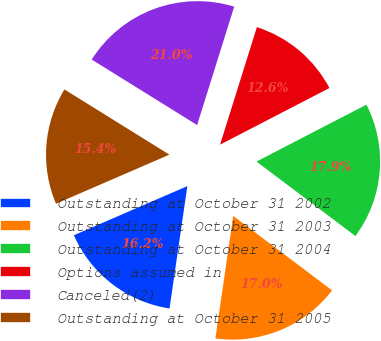Convert chart to OTSL. <chart><loc_0><loc_0><loc_500><loc_500><pie_chart><fcel>Outstanding at October 31 2002<fcel>Outstanding at October 31 2003<fcel>Outstanding at October 31 2004<fcel>Options assumed in<fcel>Canceled(2)<fcel>Outstanding at October 31 2005<nl><fcel>16.19%<fcel>17.03%<fcel>17.87%<fcel>12.56%<fcel>20.98%<fcel>15.35%<nl></chart> 